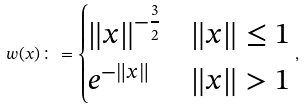<formula> <loc_0><loc_0><loc_500><loc_500>w ( x ) \colon = \begin{cases} \| x \| ^ { - \frac { 3 } { 2 } } & \| x \| \leq 1 \\ e ^ { - \| x \| } & \| x \| > 1 \end{cases} ,</formula> 